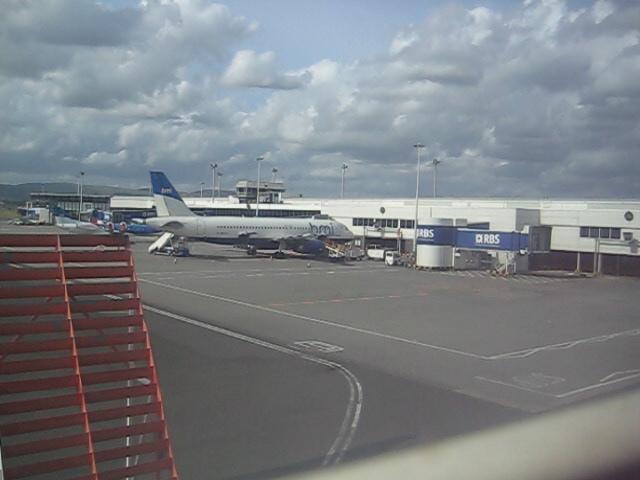Are the lines solid or dotted?
Give a very brief answer. Solid. How many planes are here?
Short answer required. 1. Are there any clouds in the sky?
Quick response, please. Yes. Is the sky cloudy?
Keep it brief. Yes. What are the solid white lines on the tarmac for?
Keep it brief. Directions. 